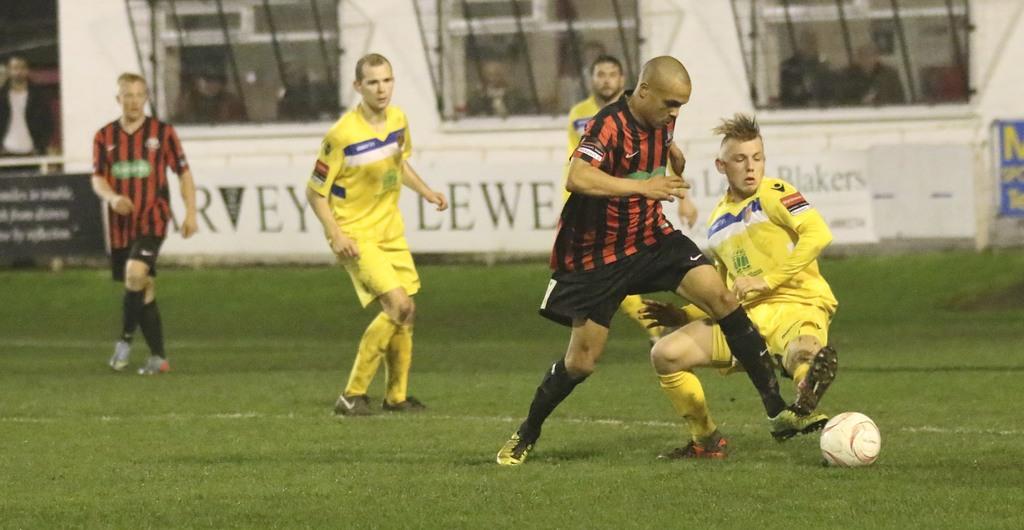What word is written on the sign above the right most player's shoulder?
Ensure brevity in your answer.  Blakers. 